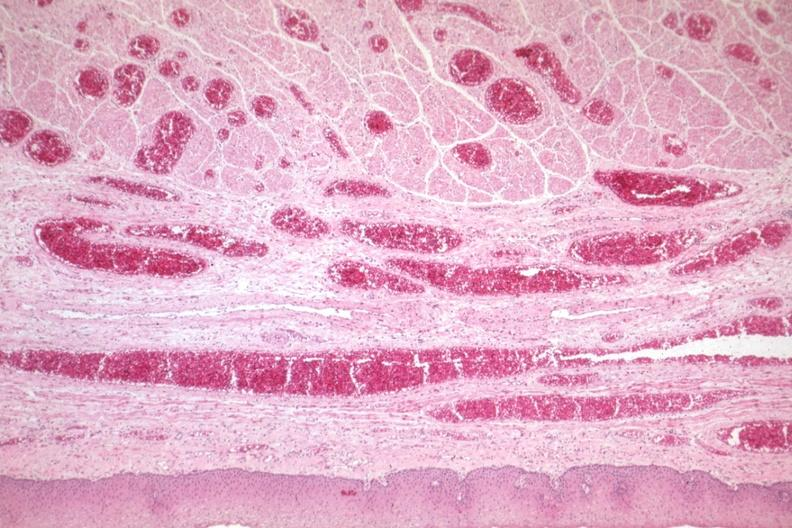what filled with blood?
Answer the question using a single word or phrase. Good example of veins 